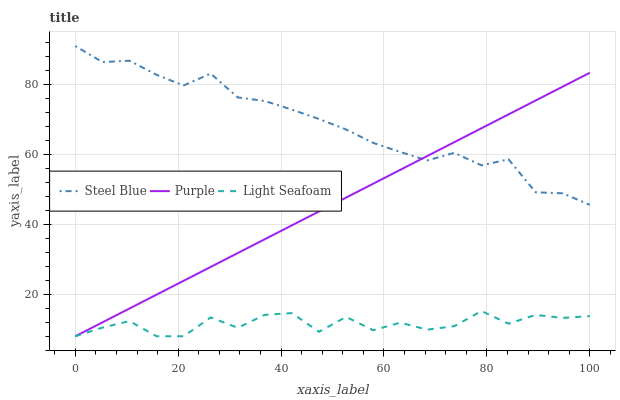Does Light Seafoam have the minimum area under the curve?
Answer yes or no. Yes. Does Steel Blue have the maximum area under the curve?
Answer yes or no. Yes. Does Steel Blue have the minimum area under the curve?
Answer yes or no. No. Does Light Seafoam have the maximum area under the curve?
Answer yes or no. No. Is Purple the smoothest?
Answer yes or no. Yes. Is Light Seafoam the roughest?
Answer yes or no. Yes. Is Steel Blue the smoothest?
Answer yes or no. No. Is Steel Blue the roughest?
Answer yes or no. No. Does Steel Blue have the lowest value?
Answer yes or no. No. Does Steel Blue have the highest value?
Answer yes or no. Yes. Does Light Seafoam have the highest value?
Answer yes or no. No. Is Light Seafoam less than Steel Blue?
Answer yes or no. Yes. Is Steel Blue greater than Light Seafoam?
Answer yes or no. Yes. Does Purple intersect Steel Blue?
Answer yes or no. Yes. Is Purple less than Steel Blue?
Answer yes or no. No. Is Purple greater than Steel Blue?
Answer yes or no. No. Does Light Seafoam intersect Steel Blue?
Answer yes or no. No. 